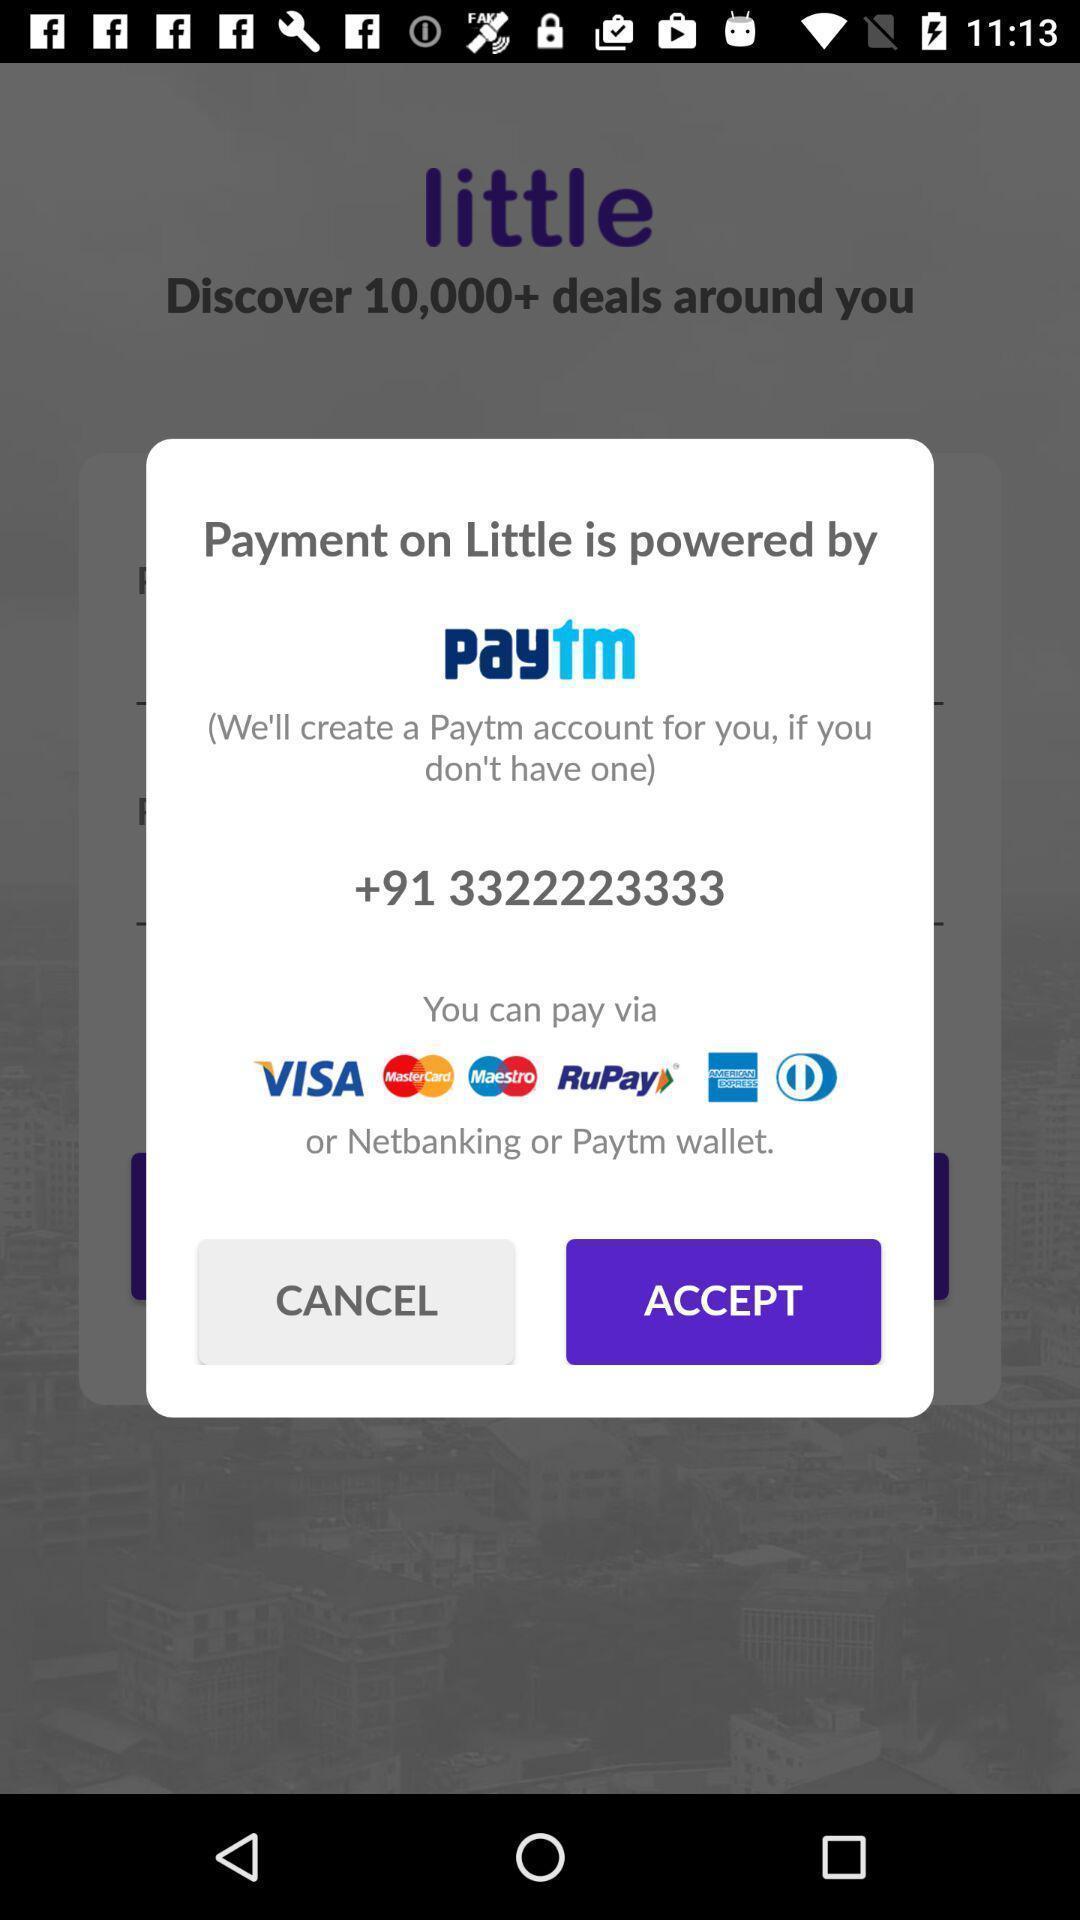Explain the elements present in this screenshot. Pop-up displaying the payment app notification. 